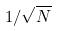<formula> <loc_0><loc_0><loc_500><loc_500>1 / \sqrt { N }</formula> 